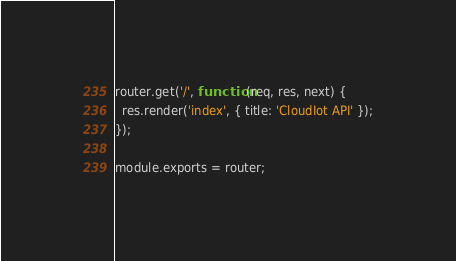<code> <loc_0><loc_0><loc_500><loc_500><_JavaScript_>router.get('/', function(req, res, next) {
  res.render('index', { title: 'CloudIot API' });
});

module.exports = router;
</code> 